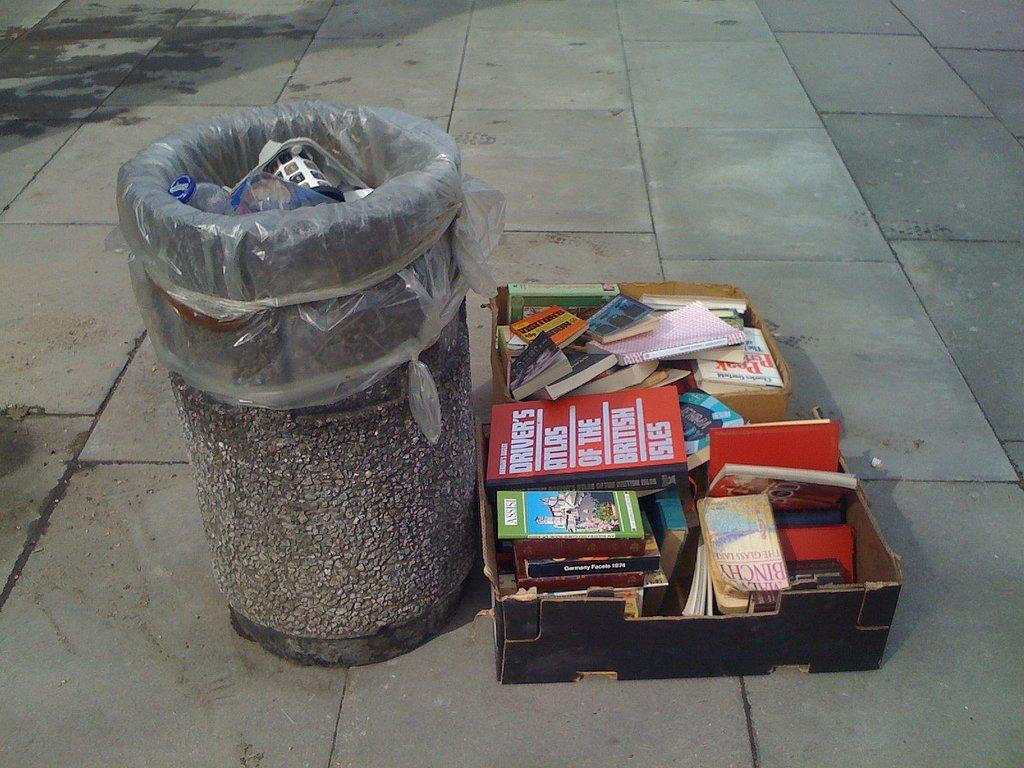<image>
Summarize the visual content of the image. a box full of books near trash can and one book titled Drivers atlas of british isles 